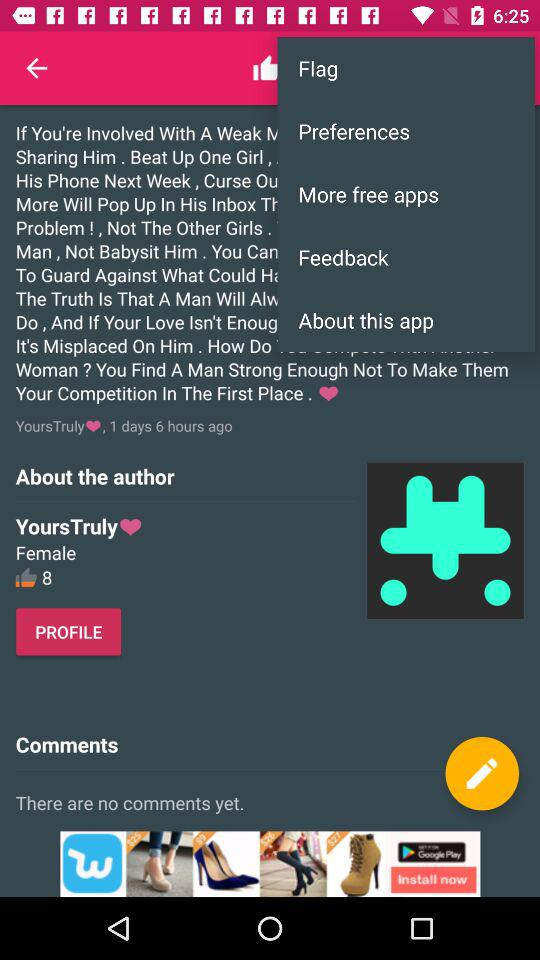What gender is mentioned there? The mentioned gender is female. 